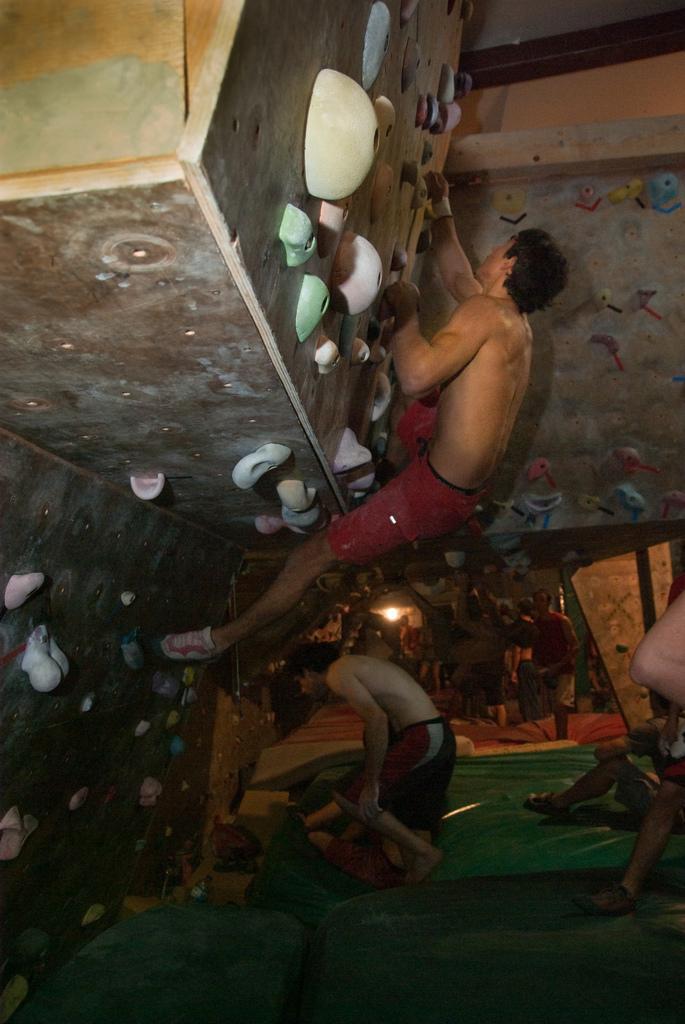How would you summarize this image in a sentence or two? On the right side there are some people. On the left side there is a indoor rock climbing wall. On that a person is climbing. 